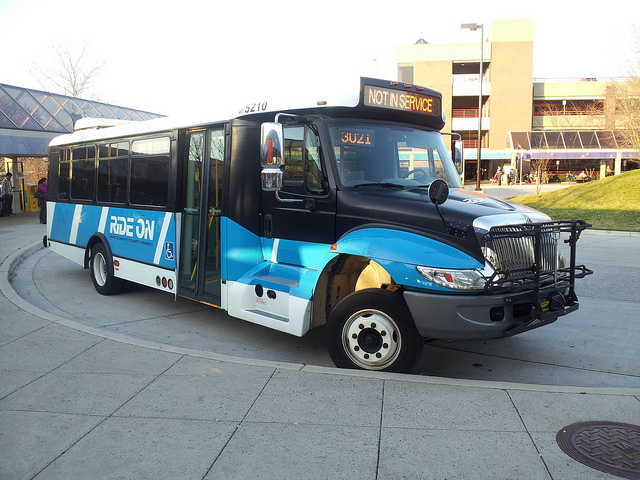Extract all visible text content from this image. 3U21 5210 NOT SERVICE RIDE N ON 